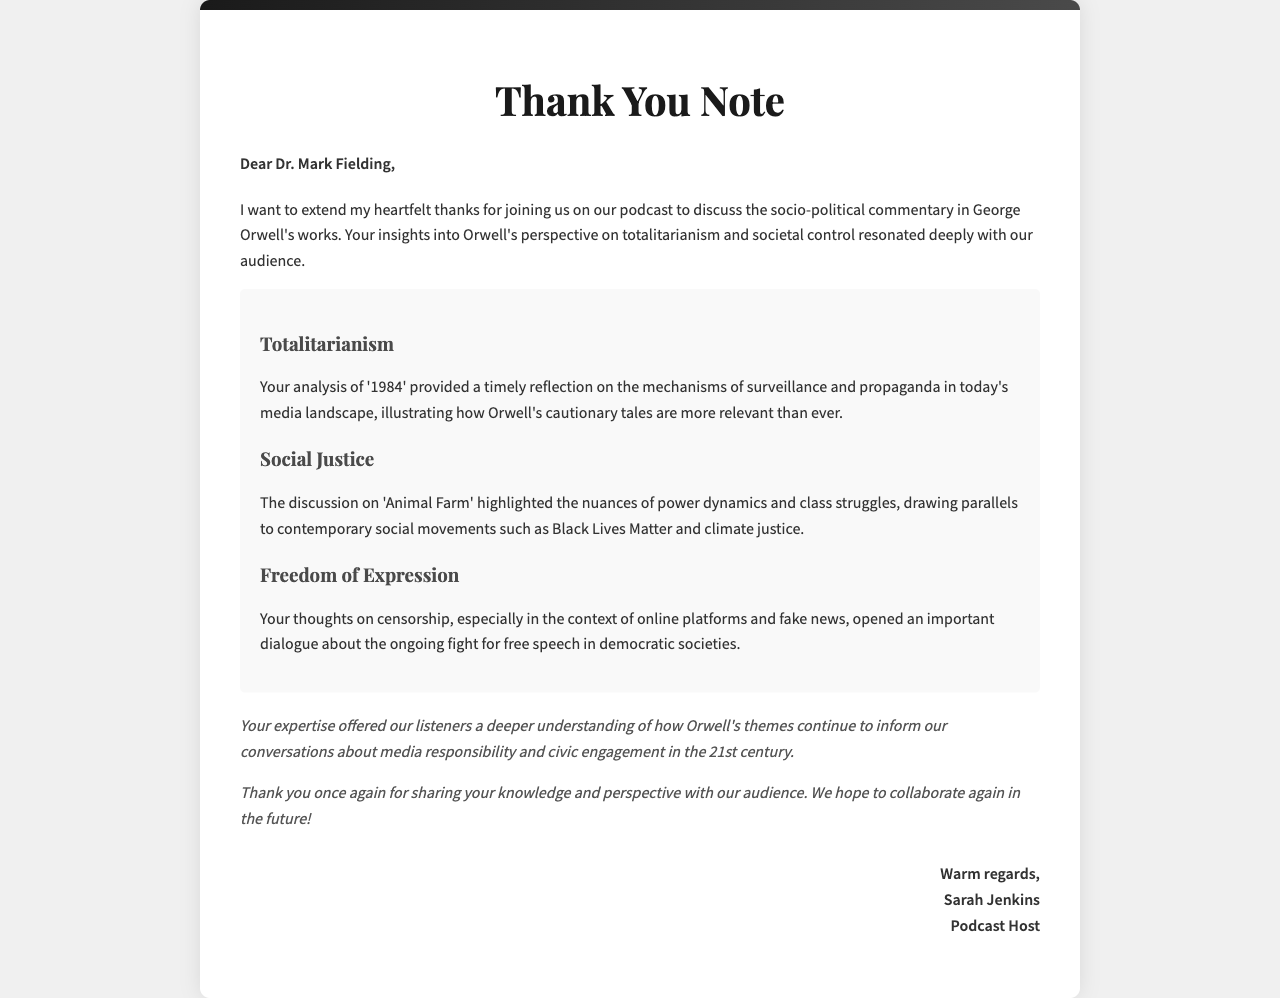What is the name of the guest speaker? The document mentions the guest speaker's name as Dr. Mark Fielding.
Answer: Dr. Mark Fielding What theme is addressed in '1984'? The document states a focus on totalitarianism in '1984'.
Answer: Totalitarianism Which social movement is mentioned in the discussion about 'Animal Farm'? The document references Black Lives Matter as a contemporary social movement.
Answer: Black Lives Matter What is the closing remark in the letter? The document concludes with a thank you and hope for future collaboration.
Answer: Thank you once again for sharing your knowledge and perspective with our audience Who is the author of the letter? The letter author is identified as Sarah Jenkins.
Answer: Sarah Jenkins What topic did the speaker discuss regarding media? The speaker discussed censorship in relation to online platforms and fake news.
Answer: Censorship How many key points are discussed in the letter? There are three key points mentioned in the letter.
Answer: Three What is the main purpose of the letter? The purpose of the letter is to express gratitude to the guest speaker.
Answer: Express gratitude 